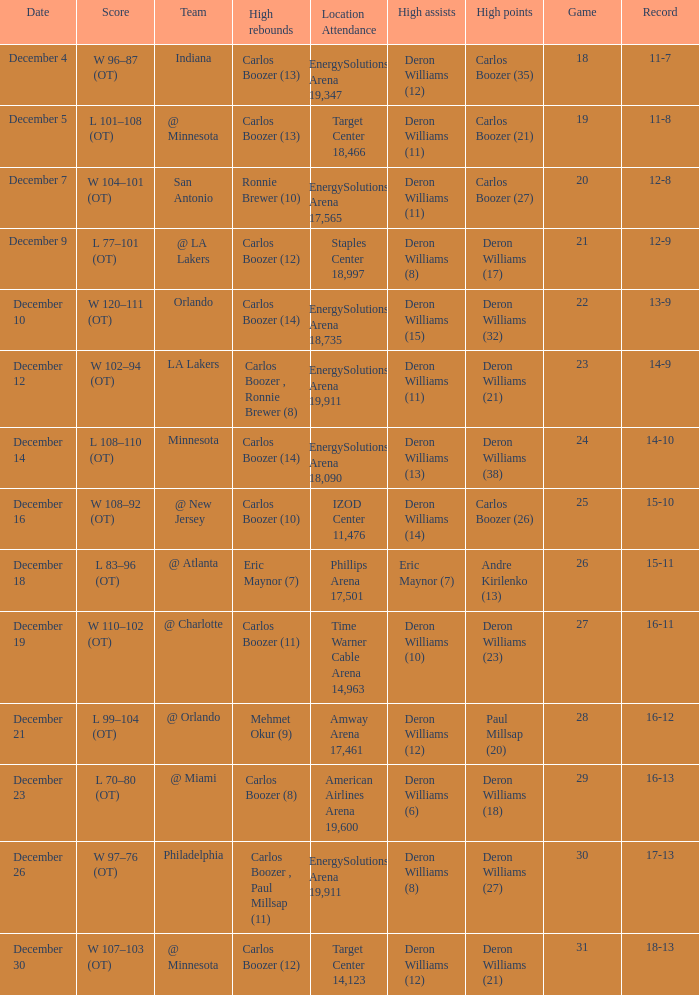How many different high rebound results are there for the game number 26? 1.0. 